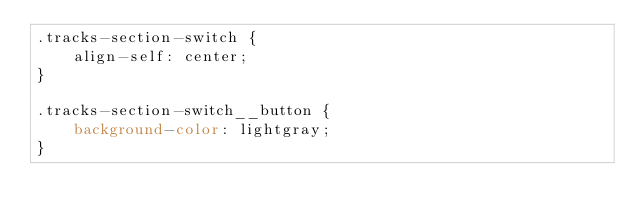<code> <loc_0><loc_0><loc_500><loc_500><_CSS_>.tracks-section-switch {
    align-self: center;
}

.tracks-section-switch__button {
    background-color: lightgray;
}</code> 